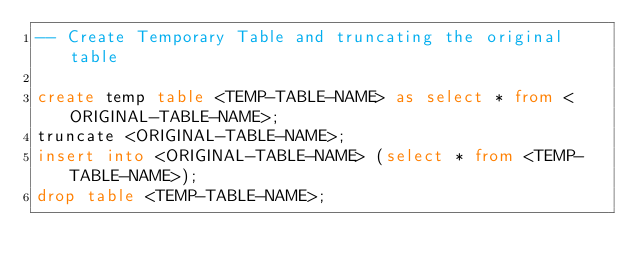Convert code to text. <code><loc_0><loc_0><loc_500><loc_500><_SQL_>-- Create Temporary Table and truncating the original table

create temp table <TEMP-TABLE-NAME> as select * from <ORIGINAL-TABLE-NAME>;
truncate <ORIGINAL-TABLE-NAME>;
insert into <ORIGINAL-TABLE-NAME> (select * from <TEMP-TABLE-NAME>);
drop table <TEMP-TABLE-NAME>;
</code> 